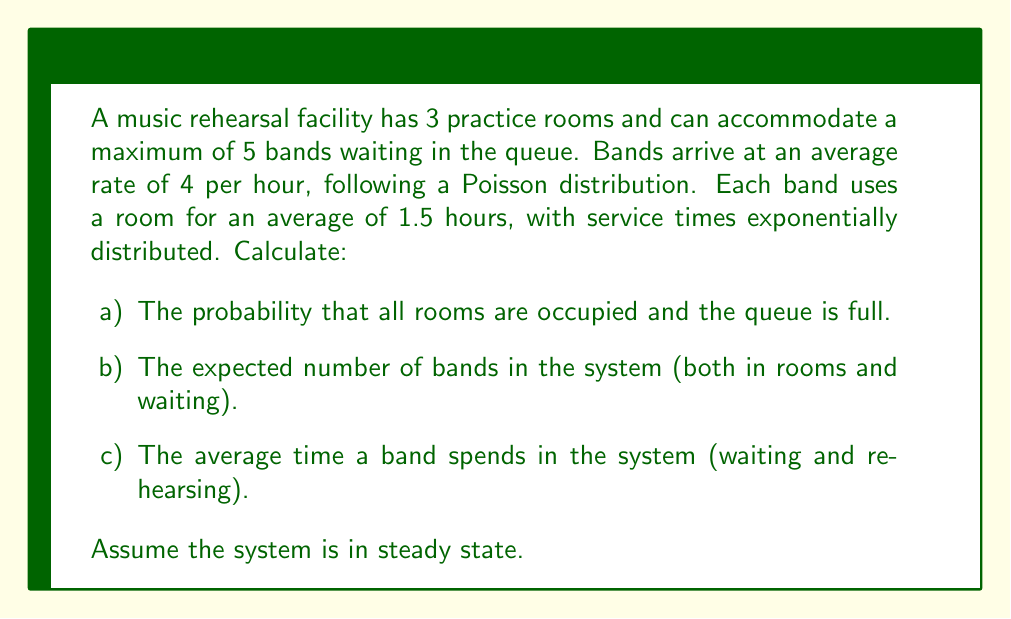Provide a solution to this math problem. This problem can be solved using the M/M/c/K queuing model, where:
M: Markovian (Poisson) arrival and service processes
c: Number of servers (practice rooms) = 3
K: System capacity (including those in service) = 8 (3 rooms + 5 waiting)

Step 1: Calculate the traffic intensity ρ
λ = 4 bands/hour (arrival rate)
μ = 1/1.5 = 2/3 bands/hour (service rate)
ρ = λ/(cμ) = 4/(3 * 2/3) = 2

Step 2: Calculate p0 (probability of an empty system)
$$p_0 = \left[\sum_{n=0}^{c-1}\frac{(c\rho)^n}{n!} + \frac{(c\rho)^c}{c!}\frac{1-(\rho)^{K-c+1}}{1-\rho}\right]^{-1}$$

Substituting the values:
$$p_0 = \left[1 + 6 + 18 + \frac{216}{6}\frac{1-(2)^6}{1-2}\right]^{-1} \approx 0.0016$$

Step 3: Calculate pK (probability that all rooms are occupied and the queue is full)
$$p_K = \frac{(c\rho)^c}{c!}\rho^{K-c}p_0$$
$$p_K = \frac{216}{6}(2)^5(0.0016) \approx 0.2765$$

Step 4: Calculate L (expected number of bands in the system)
$$L = \sum_{n=0}^K n p_n = c\rho + \frac{\rho(c\rho)^c}{c!(1-\rho)^2}p_0 \left[1-(\rho)^{K-c+1}\left(1+(K-c)(1-\rho)\right)\right]$$

Substituting values:
$$L \approx 6 + \frac{216}{6}(0.0016)\frac{1-(2)^6(1+5(-1))}{(-1)^2} \approx 6.9817$$

Step 5: Calculate W (average time a band spends in the system)
Using Little's Law: W = L/λ
$$W = 6.9817 / 4 \approx 1.7454$$ hours
Answer: a) 0.2765
b) 6.9817 bands
c) 1.7454 hours 